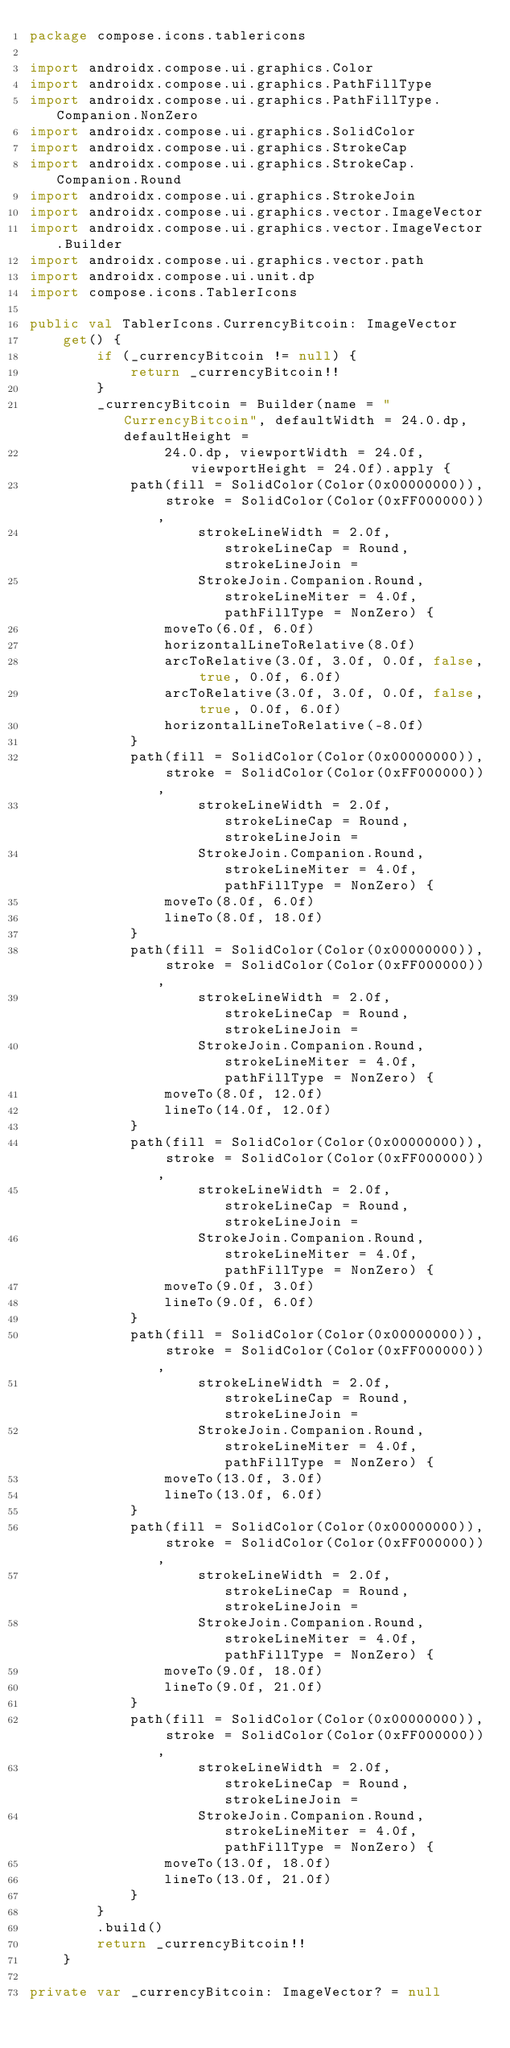<code> <loc_0><loc_0><loc_500><loc_500><_Kotlin_>package compose.icons.tablericons

import androidx.compose.ui.graphics.Color
import androidx.compose.ui.graphics.PathFillType
import androidx.compose.ui.graphics.PathFillType.Companion.NonZero
import androidx.compose.ui.graphics.SolidColor
import androidx.compose.ui.graphics.StrokeCap
import androidx.compose.ui.graphics.StrokeCap.Companion.Round
import androidx.compose.ui.graphics.StrokeJoin
import androidx.compose.ui.graphics.vector.ImageVector
import androidx.compose.ui.graphics.vector.ImageVector.Builder
import androidx.compose.ui.graphics.vector.path
import androidx.compose.ui.unit.dp
import compose.icons.TablerIcons

public val TablerIcons.CurrencyBitcoin: ImageVector
    get() {
        if (_currencyBitcoin != null) {
            return _currencyBitcoin!!
        }
        _currencyBitcoin = Builder(name = "CurrencyBitcoin", defaultWidth = 24.0.dp, defaultHeight =
                24.0.dp, viewportWidth = 24.0f, viewportHeight = 24.0f).apply {
            path(fill = SolidColor(Color(0x00000000)), stroke = SolidColor(Color(0xFF000000)),
                    strokeLineWidth = 2.0f, strokeLineCap = Round, strokeLineJoin =
                    StrokeJoin.Companion.Round, strokeLineMiter = 4.0f, pathFillType = NonZero) {
                moveTo(6.0f, 6.0f)
                horizontalLineToRelative(8.0f)
                arcToRelative(3.0f, 3.0f, 0.0f, false, true, 0.0f, 6.0f)
                arcToRelative(3.0f, 3.0f, 0.0f, false, true, 0.0f, 6.0f)
                horizontalLineToRelative(-8.0f)
            }
            path(fill = SolidColor(Color(0x00000000)), stroke = SolidColor(Color(0xFF000000)),
                    strokeLineWidth = 2.0f, strokeLineCap = Round, strokeLineJoin =
                    StrokeJoin.Companion.Round, strokeLineMiter = 4.0f, pathFillType = NonZero) {
                moveTo(8.0f, 6.0f)
                lineTo(8.0f, 18.0f)
            }
            path(fill = SolidColor(Color(0x00000000)), stroke = SolidColor(Color(0xFF000000)),
                    strokeLineWidth = 2.0f, strokeLineCap = Round, strokeLineJoin =
                    StrokeJoin.Companion.Round, strokeLineMiter = 4.0f, pathFillType = NonZero) {
                moveTo(8.0f, 12.0f)
                lineTo(14.0f, 12.0f)
            }
            path(fill = SolidColor(Color(0x00000000)), stroke = SolidColor(Color(0xFF000000)),
                    strokeLineWidth = 2.0f, strokeLineCap = Round, strokeLineJoin =
                    StrokeJoin.Companion.Round, strokeLineMiter = 4.0f, pathFillType = NonZero) {
                moveTo(9.0f, 3.0f)
                lineTo(9.0f, 6.0f)
            }
            path(fill = SolidColor(Color(0x00000000)), stroke = SolidColor(Color(0xFF000000)),
                    strokeLineWidth = 2.0f, strokeLineCap = Round, strokeLineJoin =
                    StrokeJoin.Companion.Round, strokeLineMiter = 4.0f, pathFillType = NonZero) {
                moveTo(13.0f, 3.0f)
                lineTo(13.0f, 6.0f)
            }
            path(fill = SolidColor(Color(0x00000000)), stroke = SolidColor(Color(0xFF000000)),
                    strokeLineWidth = 2.0f, strokeLineCap = Round, strokeLineJoin =
                    StrokeJoin.Companion.Round, strokeLineMiter = 4.0f, pathFillType = NonZero) {
                moveTo(9.0f, 18.0f)
                lineTo(9.0f, 21.0f)
            }
            path(fill = SolidColor(Color(0x00000000)), stroke = SolidColor(Color(0xFF000000)),
                    strokeLineWidth = 2.0f, strokeLineCap = Round, strokeLineJoin =
                    StrokeJoin.Companion.Round, strokeLineMiter = 4.0f, pathFillType = NonZero) {
                moveTo(13.0f, 18.0f)
                lineTo(13.0f, 21.0f)
            }
        }
        .build()
        return _currencyBitcoin!!
    }

private var _currencyBitcoin: ImageVector? = null
</code> 